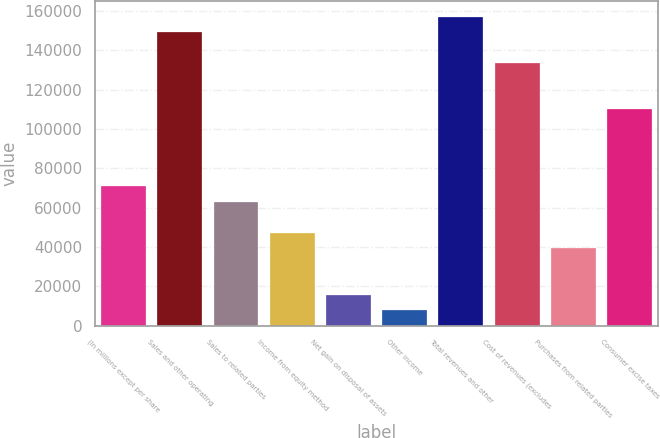<chart> <loc_0><loc_0><loc_500><loc_500><bar_chart><fcel>(In millions except per share<fcel>Sales and other operating<fcel>Sales to related parties<fcel>Income from equity method<fcel>Net gain on disposal of assets<fcel>Other income<fcel>Total revenues and other<fcel>Cost of revenues (excludes<fcel>Purchases from related parties<fcel>Consumer excise taxes<nl><fcel>70717.1<fcel>149236<fcel>62865.2<fcel>47161.4<fcel>15753.8<fcel>7901.9<fcel>157088<fcel>133532<fcel>39309.5<fcel>109977<nl></chart> 